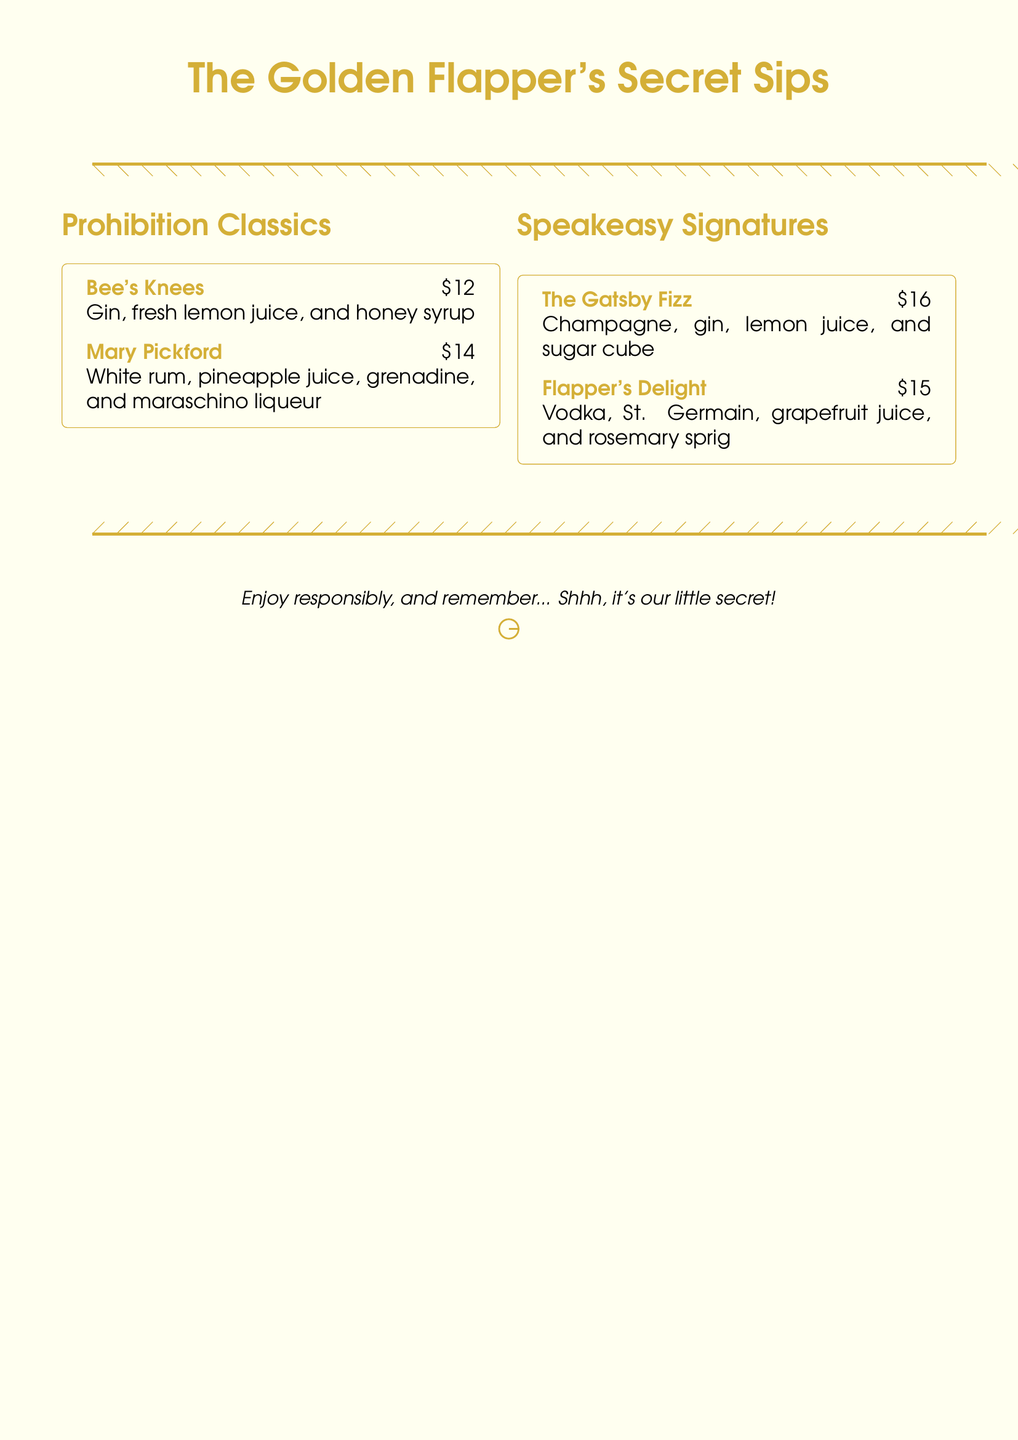What is the title of the menu? The title is prominently displayed at the top of the menu in a large font.
Answer: The Golden Flapper's Secret Sips How many Prohibition Classics are listed? The menu lists two Prohibition Classics under the specified section.
Answer: 2 What is the price of The Gatsby Fizz? The price is clearly stated next to the drink name in the Speakeasy Signatures section.
Answer: $16 What ingredient is in Bee's Knees? The ingredients for Bee's Knees are listed directly below its name.
Answer: Gin Which cocktail features rosemary? The menu specifies the ingredient and the cocktail name in the Speakeasy Signatures section.
Answer: Flapper's Delight What color accents are used throughout the menu? The color accents are evident in the title, section headings, and border designs of the menu.
Answer: Gold foil What type of drinks are showcased? The menu explicitly categorizes the drinks as coming from a specific era and theme.
Answer: Prohibition-era cocktails What is the intended message at the bottom of the menu? The message is designed to convey a sense of secrecy and encourage responsible consumption.
Answer: Shhh, it's our little secret! 